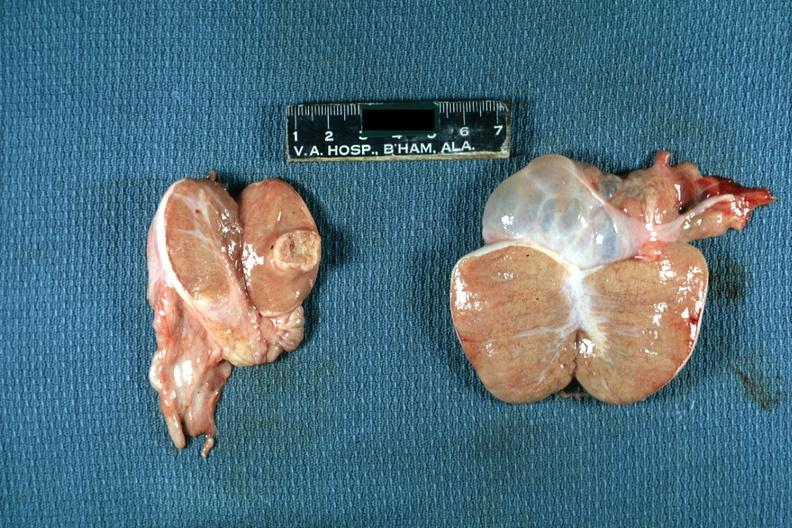what does this image show?
Answer the question using a single word or phrase. Discrete yellow mass lesion in one testicle hydrocele in other 